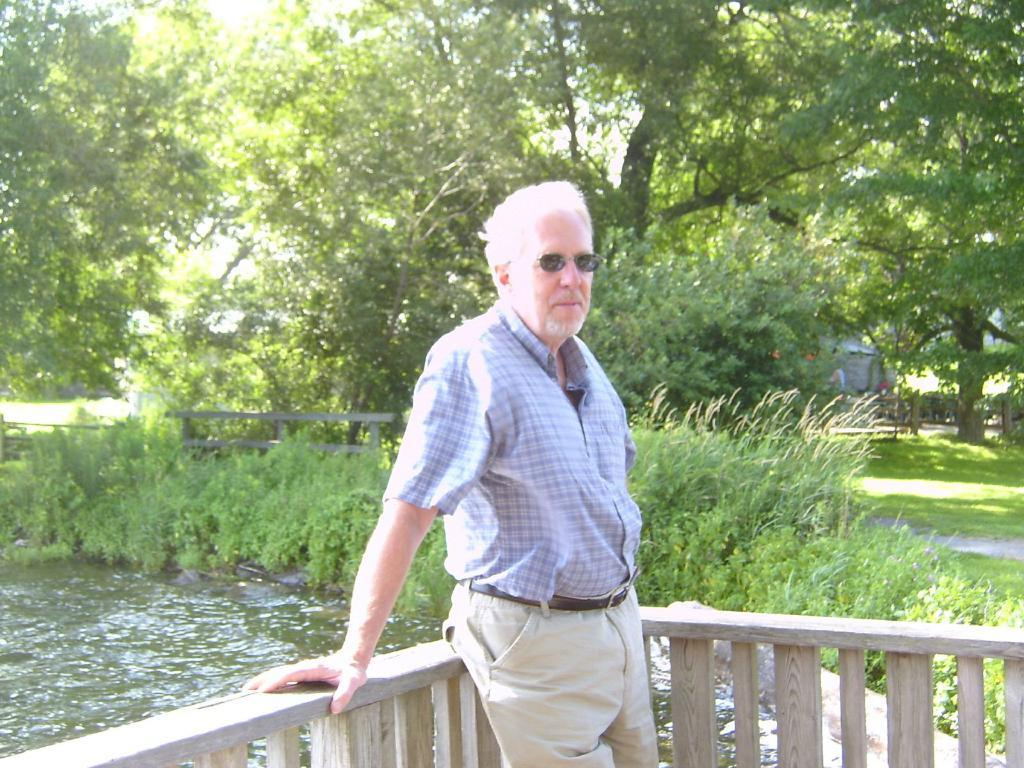Who is the main subject in the picture? There is a man in the picture. What is the man standing near? The man is standing near a wooden fence. What can be seen behind the man? There is water visible behind the man. What type of vegetation is present in the image? There are plants and trees present in the image. What type of needle is the man using to sew the brick in the image? There is no needle or brick present in the image; it features a man standing near a wooden fence with water and vegetation in the background. 